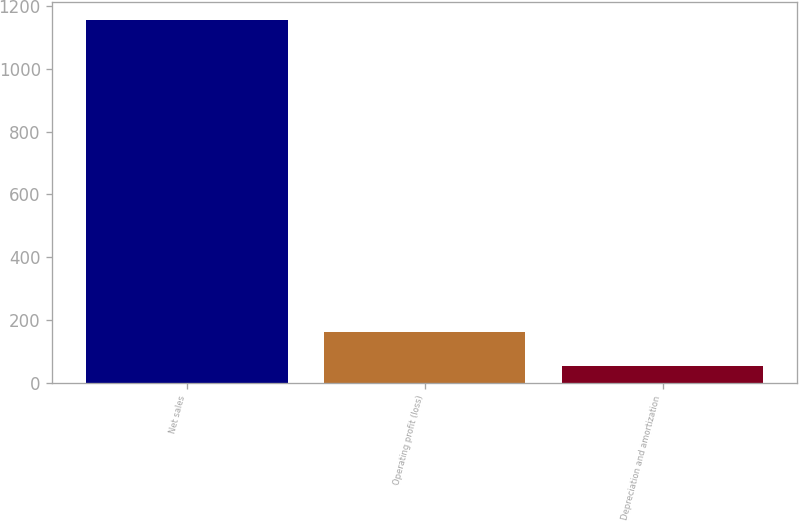<chart> <loc_0><loc_0><loc_500><loc_500><bar_chart><fcel>Net sales<fcel>Operating profit (loss)<fcel>Depreciation and amortization<nl><fcel>1155<fcel>162.3<fcel>52<nl></chart> 